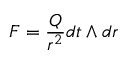<formula> <loc_0><loc_0><loc_500><loc_500>F = \frac { Q } { r ^ { 2 } } d t \wedge d r</formula> 